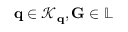Convert formula to latex. <formula><loc_0><loc_0><loc_500><loc_500>q \in \mathcal { K } _ { q } , G \in \mathbb { L }</formula> 